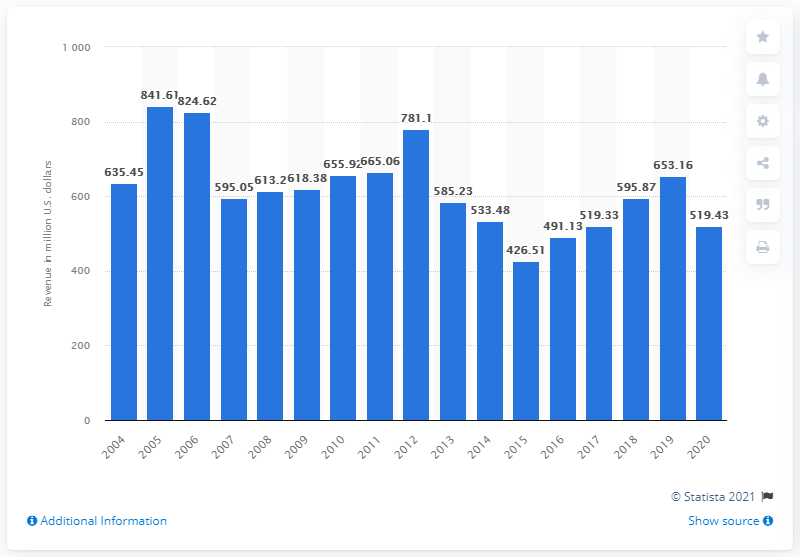List a handful of essential elements in this visual. Endeavor Air's total revenue in 2020 was approximately 519.43 dollars. 